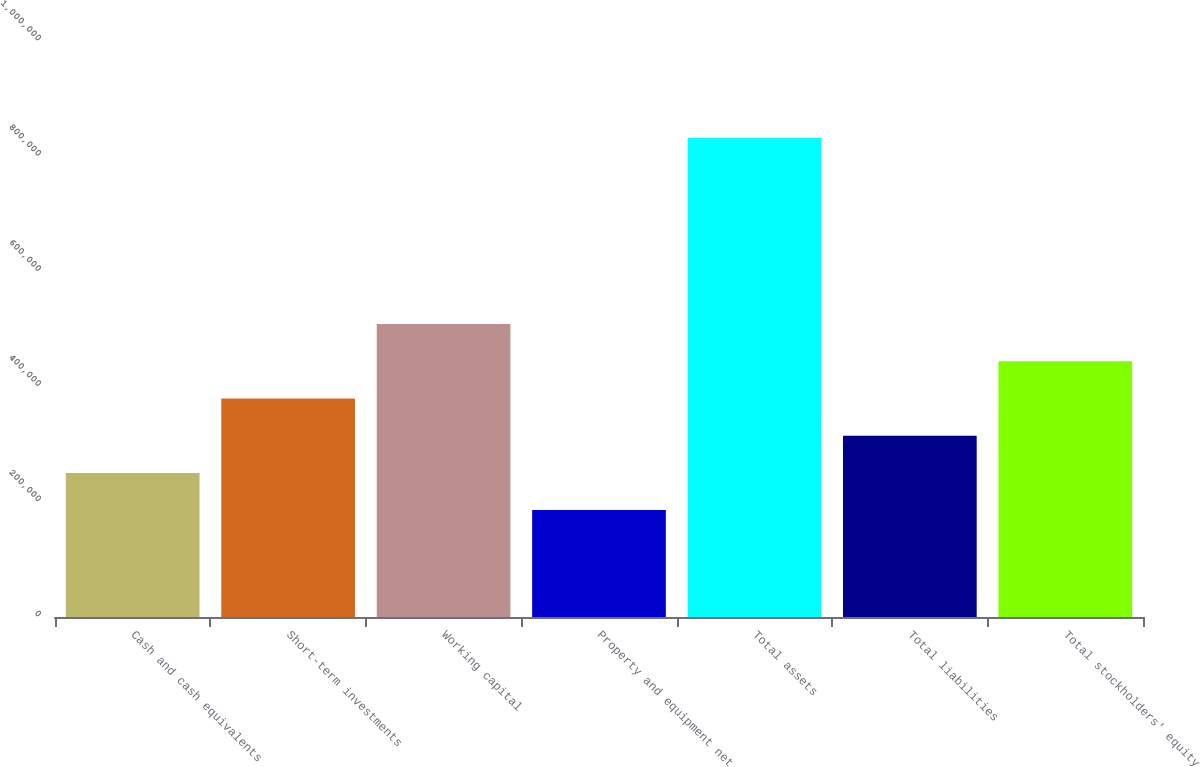Convert chart. <chart><loc_0><loc_0><loc_500><loc_500><bar_chart><fcel>Cash and cash equivalents<fcel>Short-term investments<fcel>Working capital<fcel>Property and equipment net<fcel>Total assets<fcel>Total liabilities<fcel>Total stockholders' equity<nl><fcel>250173<fcel>379372<fcel>508571<fcel>185574<fcel>831568<fcel>314773<fcel>443972<nl></chart> 